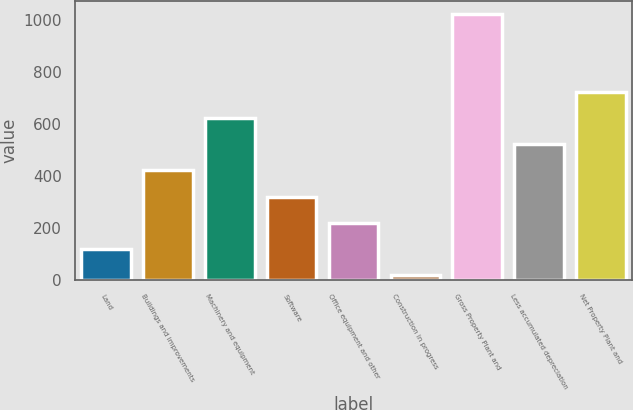<chart> <loc_0><loc_0><loc_500><loc_500><bar_chart><fcel>Land<fcel>Buildings and improvements<fcel>Machinery and equipment<fcel>Software<fcel>Office equipment and other<fcel>Construction in progress<fcel>Gross Property Plant and<fcel>Less accumulated depreciation<fcel>Net Property Plant and<nl><fcel>121.12<fcel>421.48<fcel>621.72<fcel>321.36<fcel>221.24<fcel>21<fcel>1022.2<fcel>521.6<fcel>721.84<nl></chart> 